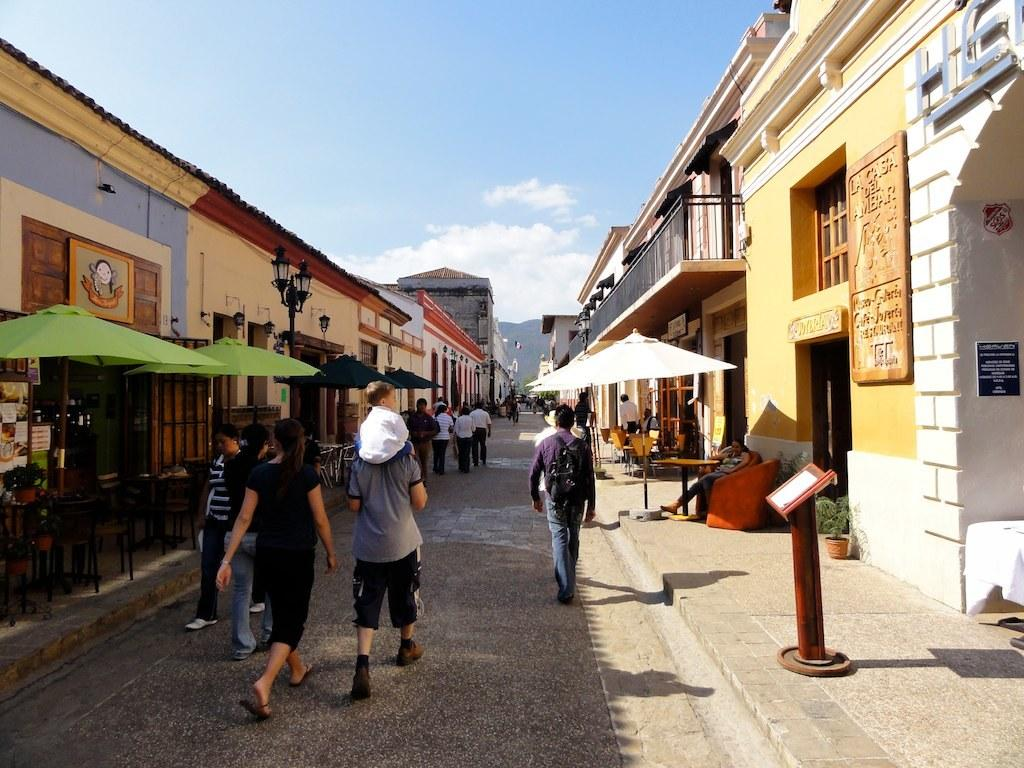What are the people in the image doing? The people in the image are walking on the road. What can be seen beside the road? There are buildings beside the road. What is in front of the buildings? There are tents in front of the buildings. What else can be seen in the image? There are electric poles with lights in the image. How many boys are attacking the electric poles in the image? There are no boys or attacks present in the image. What type of wrench is being used to fix the lights on the electric poles? There is no wrench or repair work being done on the electric poles in the image. 